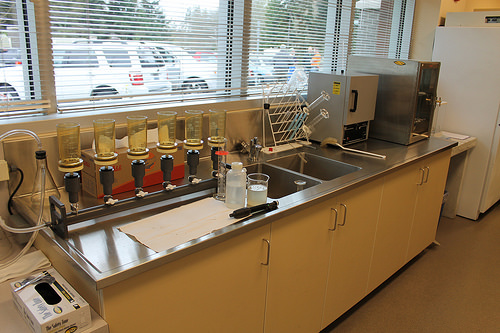<image>
Is the table behind the window? Yes. From this viewpoint, the table is positioned behind the window, with the window partially or fully occluding the table. Is there a gloves on the counter? No. The gloves is not positioned on the counter. They may be near each other, but the gloves is not supported by or resting on top of the counter. 